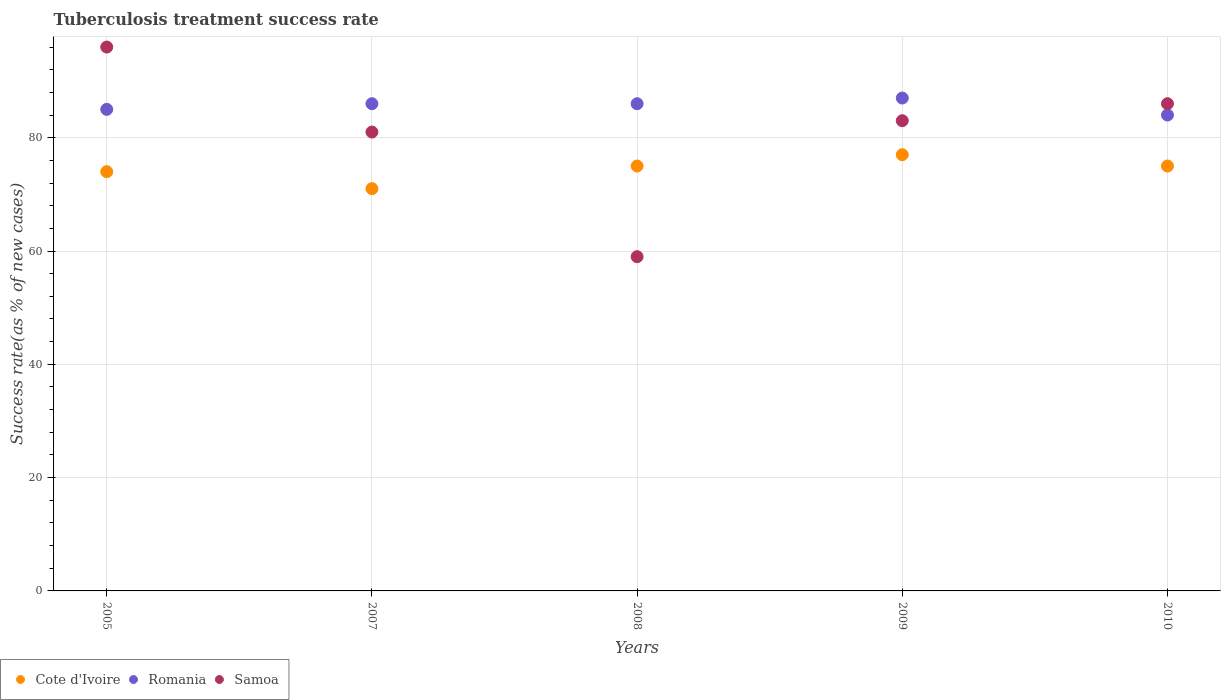Is the number of dotlines equal to the number of legend labels?
Offer a very short reply. Yes. What is the tuberculosis treatment success rate in Cote d'Ivoire in 2010?
Your answer should be very brief. 75. Across all years, what is the maximum tuberculosis treatment success rate in Romania?
Give a very brief answer. 87. Across all years, what is the minimum tuberculosis treatment success rate in Romania?
Provide a short and direct response. 84. In which year was the tuberculosis treatment success rate in Romania maximum?
Offer a terse response. 2009. In which year was the tuberculosis treatment success rate in Samoa minimum?
Your response must be concise. 2008. What is the total tuberculosis treatment success rate in Samoa in the graph?
Provide a succinct answer. 405. What is the difference between the tuberculosis treatment success rate in Romania in 2005 and the tuberculosis treatment success rate in Cote d'Ivoire in 2010?
Provide a succinct answer. 10. In the year 2008, what is the difference between the tuberculosis treatment success rate in Romania and tuberculosis treatment success rate in Cote d'Ivoire?
Keep it short and to the point. 11. In how many years, is the tuberculosis treatment success rate in Samoa greater than 20 %?
Your answer should be compact. 5. What is the ratio of the tuberculosis treatment success rate in Romania in 2005 to that in 2007?
Give a very brief answer. 0.99. What is the difference between the highest and the lowest tuberculosis treatment success rate in Romania?
Your response must be concise. 3. Is the sum of the tuberculosis treatment success rate in Romania in 2008 and 2010 greater than the maximum tuberculosis treatment success rate in Cote d'Ivoire across all years?
Ensure brevity in your answer.  Yes. How many dotlines are there?
Offer a terse response. 3. What is the difference between two consecutive major ticks on the Y-axis?
Offer a terse response. 20. Are the values on the major ticks of Y-axis written in scientific E-notation?
Provide a succinct answer. No. Does the graph contain any zero values?
Provide a succinct answer. No. Does the graph contain grids?
Offer a terse response. Yes. How many legend labels are there?
Provide a succinct answer. 3. How are the legend labels stacked?
Your response must be concise. Horizontal. What is the title of the graph?
Your response must be concise. Tuberculosis treatment success rate. Does "New Caledonia" appear as one of the legend labels in the graph?
Ensure brevity in your answer.  No. What is the label or title of the X-axis?
Your response must be concise. Years. What is the label or title of the Y-axis?
Your response must be concise. Success rate(as % of new cases). What is the Success rate(as % of new cases) in Samoa in 2005?
Ensure brevity in your answer.  96. What is the Success rate(as % of new cases) in Romania in 2007?
Provide a short and direct response. 86. What is the Success rate(as % of new cases) of Samoa in 2007?
Your response must be concise. 81. What is the Success rate(as % of new cases) of Cote d'Ivoire in 2009?
Offer a very short reply. 77. What is the Success rate(as % of new cases) in Cote d'Ivoire in 2010?
Keep it short and to the point. 75. Across all years, what is the maximum Success rate(as % of new cases) of Samoa?
Your answer should be very brief. 96. Across all years, what is the minimum Success rate(as % of new cases) of Romania?
Provide a succinct answer. 84. What is the total Success rate(as % of new cases) in Cote d'Ivoire in the graph?
Your response must be concise. 372. What is the total Success rate(as % of new cases) of Romania in the graph?
Make the answer very short. 428. What is the total Success rate(as % of new cases) of Samoa in the graph?
Provide a succinct answer. 405. What is the difference between the Success rate(as % of new cases) of Cote d'Ivoire in 2005 and that in 2007?
Give a very brief answer. 3. What is the difference between the Success rate(as % of new cases) of Romania in 2005 and that in 2007?
Offer a terse response. -1. What is the difference between the Success rate(as % of new cases) of Samoa in 2005 and that in 2007?
Offer a very short reply. 15. What is the difference between the Success rate(as % of new cases) in Cote d'Ivoire in 2005 and that in 2008?
Provide a succinct answer. -1. What is the difference between the Success rate(as % of new cases) in Romania in 2005 and that in 2008?
Keep it short and to the point. -1. What is the difference between the Success rate(as % of new cases) in Cote d'Ivoire in 2005 and that in 2009?
Your answer should be very brief. -3. What is the difference between the Success rate(as % of new cases) of Romania in 2005 and that in 2009?
Offer a terse response. -2. What is the difference between the Success rate(as % of new cases) of Samoa in 2007 and that in 2008?
Provide a succinct answer. 22. What is the difference between the Success rate(as % of new cases) of Romania in 2007 and that in 2010?
Provide a succinct answer. 2. What is the difference between the Success rate(as % of new cases) in Samoa in 2007 and that in 2010?
Your answer should be compact. -5. What is the difference between the Success rate(as % of new cases) of Cote d'Ivoire in 2008 and that in 2009?
Your answer should be compact. -2. What is the difference between the Success rate(as % of new cases) of Cote d'Ivoire in 2008 and that in 2010?
Your answer should be very brief. 0. What is the difference between the Success rate(as % of new cases) of Romania in 2008 and that in 2010?
Your answer should be compact. 2. What is the difference between the Success rate(as % of new cases) in Romania in 2009 and that in 2010?
Keep it short and to the point. 3. What is the difference between the Success rate(as % of new cases) of Romania in 2005 and the Success rate(as % of new cases) of Samoa in 2007?
Provide a short and direct response. 4. What is the difference between the Success rate(as % of new cases) of Cote d'Ivoire in 2005 and the Success rate(as % of new cases) of Romania in 2008?
Ensure brevity in your answer.  -12. What is the difference between the Success rate(as % of new cases) in Romania in 2005 and the Success rate(as % of new cases) in Samoa in 2008?
Offer a very short reply. 26. What is the difference between the Success rate(as % of new cases) of Cote d'Ivoire in 2005 and the Success rate(as % of new cases) of Romania in 2009?
Provide a short and direct response. -13. What is the difference between the Success rate(as % of new cases) in Romania in 2005 and the Success rate(as % of new cases) in Samoa in 2009?
Ensure brevity in your answer.  2. What is the difference between the Success rate(as % of new cases) in Cote d'Ivoire in 2005 and the Success rate(as % of new cases) in Romania in 2010?
Make the answer very short. -10. What is the difference between the Success rate(as % of new cases) in Romania in 2005 and the Success rate(as % of new cases) in Samoa in 2010?
Your answer should be very brief. -1. What is the difference between the Success rate(as % of new cases) in Cote d'Ivoire in 2007 and the Success rate(as % of new cases) in Romania in 2008?
Provide a succinct answer. -15. What is the difference between the Success rate(as % of new cases) of Cote d'Ivoire in 2007 and the Success rate(as % of new cases) of Samoa in 2008?
Make the answer very short. 12. What is the difference between the Success rate(as % of new cases) of Romania in 2007 and the Success rate(as % of new cases) of Samoa in 2008?
Offer a terse response. 27. What is the difference between the Success rate(as % of new cases) in Cote d'Ivoire in 2007 and the Success rate(as % of new cases) in Romania in 2009?
Your answer should be very brief. -16. What is the difference between the Success rate(as % of new cases) in Cote d'Ivoire in 2007 and the Success rate(as % of new cases) in Romania in 2010?
Make the answer very short. -13. What is the difference between the Success rate(as % of new cases) in Romania in 2007 and the Success rate(as % of new cases) in Samoa in 2010?
Your answer should be very brief. 0. What is the difference between the Success rate(as % of new cases) of Cote d'Ivoire in 2008 and the Success rate(as % of new cases) of Romania in 2009?
Offer a terse response. -12. What is the difference between the Success rate(as % of new cases) of Cote d'Ivoire in 2008 and the Success rate(as % of new cases) of Romania in 2010?
Provide a succinct answer. -9. What is the difference between the Success rate(as % of new cases) of Cote d'Ivoire in 2008 and the Success rate(as % of new cases) of Samoa in 2010?
Ensure brevity in your answer.  -11. What is the average Success rate(as % of new cases) in Cote d'Ivoire per year?
Make the answer very short. 74.4. What is the average Success rate(as % of new cases) in Romania per year?
Make the answer very short. 85.6. In the year 2005, what is the difference between the Success rate(as % of new cases) in Cote d'Ivoire and Success rate(as % of new cases) in Romania?
Keep it short and to the point. -11. In the year 2007, what is the difference between the Success rate(as % of new cases) in Cote d'Ivoire and Success rate(as % of new cases) in Romania?
Ensure brevity in your answer.  -15. In the year 2007, what is the difference between the Success rate(as % of new cases) in Cote d'Ivoire and Success rate(as % of new cases) in Samoa?
Provide a short and direct response. -10. In the year 2008, what is the difference between the Success rate(as % of new cases) of Romania and Success rate(as % of new cases) of Samoa?
Make the answer very short. 27. In the year 2009, what is the difference between the Success rate(as % of new cases) of Cote d'Ivoire and Success rate(as % of new cases) of Romania?
Provide a short and direct response. -10. In the year 2009, what is the difference between the Success rate(as % of new cases) in Cote d'Ivoire and Success rate(as % of new cases) in Samoa?
Ensure brevity in your answer.  -6. In the year 2010, what is the difference between the Success rate(as % of new cases) in Romania and Success rate(as % of new cases) in Samoa?
Offer a terse response. -2. What is the ratio of the Success rate(as % of new cases) in Cote d'Ivoire in 2005 to that in 2007?
Give a very brief answer. 1.04. What is the ratio of the Success rate(as % of new cases) of Romania in 2005 to that in 2007?
Give a very brief answer. 0.99. What is the ratio of the Success rate(as % of new cases) in Samoa in 2005 to that in 2007?
Ensure brevity in your answer.  1.19. What is the ratio of the Success rate(as % of new cases) in Cote d'Ivoire in 2005 to that in 2008?
Give a very brief answer. 0.99. What is the ratio of the Success rate(as % of new cases) in Romania in 2005 to that in 2008?
Offer a very short reply. 0.99. What is the ratio of the Success rate(as % of new cases) of Samoa in 2005 to that in 2008?
Your answer should be compact. 1.63. What is the ratio of the Success rate(as % of new cases) in Cote d'Ivoire in 2005 to that in 2009?
Make the answer very short. 0.96. What is the ratio of the Success rate(as % of new cases) in Samoa in 2005 to that in 2009?
Offer a terse response. 1.16. What is the ratio of the Success rate(as % of new cases) of Cote d'Ivoire in 2005 to that in 2010?
Offer a terse response. 0.99. What is the ratio of the Success rate(as % of new cases) of Romania in 2005 to that in 2010?
Your response must be concise. 1.01. What is the ratio of the Success rate(as % of new cases) in Samoa in 2005 to that in 2010?
Provide a succinct answer. 1.12. What is the ratio of the Success rate(as % of new cases) of Cote d'Ivoire in 2007 to that in 2008?
Give a very brief answer. 0.95. What is the ratio of the Success rate(as % of new cases) of Romania in 2007 to that in 2008?
Ensure brevity in your answer.  1. What is the ratio of the Success rate(as % of new cases) in Samoa in 2007 to that in 2008?
Offer a very short reply. 1.37. What is the ratio of the Success rate(as % of new cases) of Cote d'Ivoire in 2007 to that in 2009?
Your answer should be compact. 0.92. What is the ratio of the Success rate(as % of new cases) of Romania in 2007 to that in 2009?
Provide a succinct answer. 0.99. What is the ratio of the Success rate(as % of new cases) in Samoa in 2007 to that in 2009?
Your answer should be very brief. 0.98. What is the ratio of the Success rate(as % of new cases) of Cote d'Ivoire in 2007 to that in 2010?
Provide a succinct answer. 0.95. What is the ratio of the Success rate(as % of new cases) of Romania in 2007 to that in 2010?
Give a very brief answer. 1.02. What is the ratio of the Success rate(as % of new cases) in Samoa in 2007 to that in 2010?
Ensure brevity in your answer.  0.94. What is the ratio of the Success rate(as % of new cases) in Cote d'Ivoire in 2008 to that in 2009?
Keep it short and to the point. 0.97. What is the ratio of the Success rate(as % of new cases) in Samoa in 2008 to that in 2009?
Your answer should be compact. 0.71. What is the ratio of the Success rate(as % of new cases) in Cote d'Ivoire in 2008 to that in 2010?
Your answer should be very brief. 1. What is the ratio of the Success rate(as % of new cases) of Romania in 2008 to that in 2010?
Keep it short and to the point. 1.02. What is the ratio of the Success rate(as % of new cases) of Samoa in 2008 to that in 2010?
Give a very brief answer. 0.69. What is the ratio of the Success rate(as % of new cases) in Cote d'Ivoire in 2009 to that in 2010?
Ensure brevity in your answer.  1.03. What is the ratio of the Success rate(as % of new cases) of Romania in 2009 to that in 2010?
Offer a very short reply. 1.04. What is the ratio of the Success rate(as % of new cases) of Samoa in 2009 to that in 2010?
Provide a succinct answer. 0.97. What is the difference between the highest and the second highest Success rate(as % of new cases) in Romania?
Give a very brief answer. 1. What is the difference between the highest and the lowest Success rate(as % of new cases) of Cote d'Ivoire?
Offer a terse response. 6. What is the difference between the highest and the lowest Success rate(as % of new cases) of Romania?
Offer a terse response. 3. What is the difference between the highest and the lowest Success rate(as % of new cases) of Samoa?
Your response must be concise. 37. 